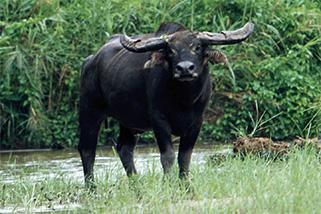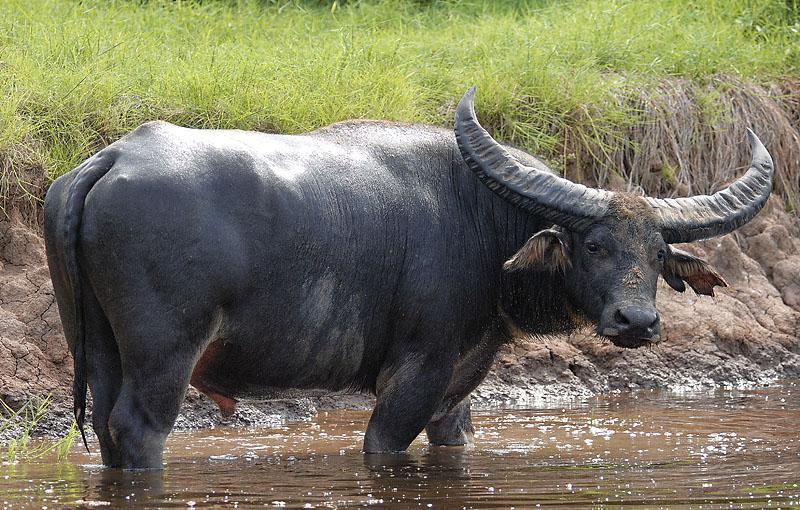The first image is the image on the left, the second image is the image on the right. Evaluate the accuracy of this statement regarding the images: "At least 3 cows are standing in a grassy field.". Is it true? Answer yes or no. No. 